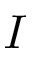<formula> <loc_0><loc_0><loc_500><loc_500>I</formula> 